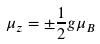<formula> <loc_0><loc_0><loc_500><loc_500>\mu _ { z } = \pm \frac { 1 } { 2 } g \mu _ { B }</formula> 